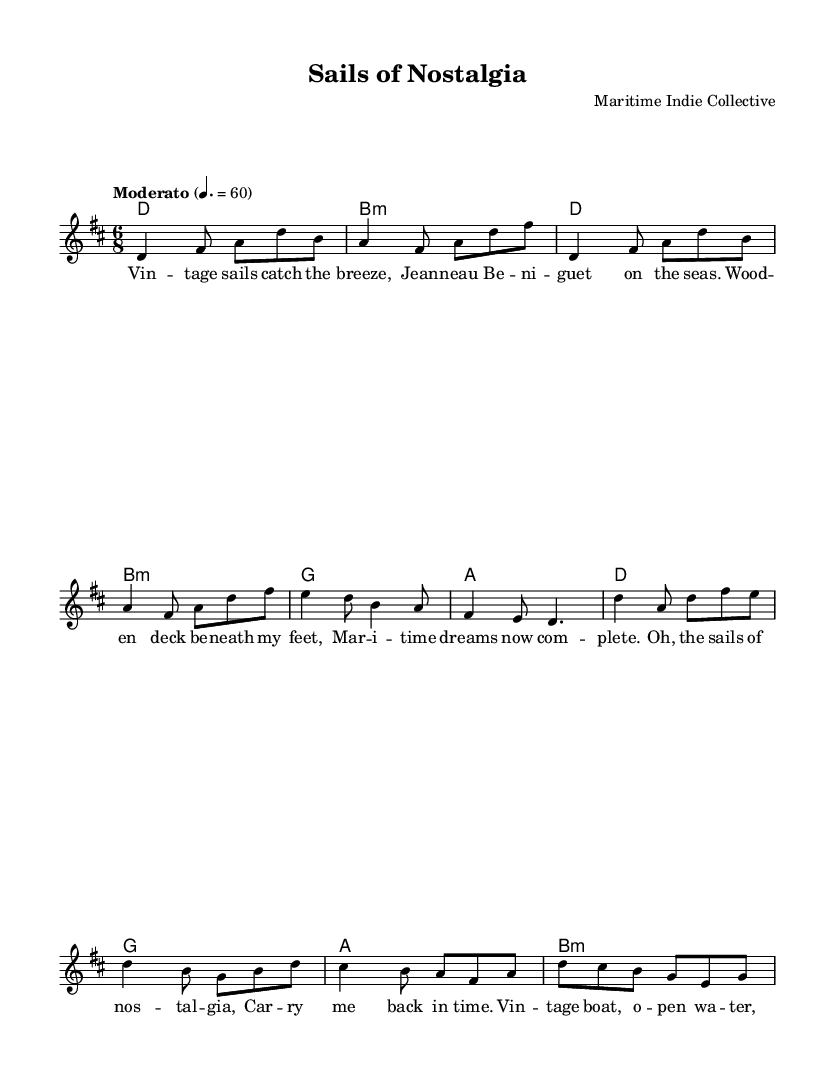What is the key signature of this music? The key signature is indicated at the beginning of the score, showing two sharps. This corresponds to the D major scale.
Answer: D major What is the time signature of this music? The time signature is shown at the beginning of the score as 6/8, indicating there are six eighth notes per measure.
Answer: 6/8 What is the tempo marking for this piece? The tempo is marked "Moderato" and also includes a metronome marking of quarter note equals 60. This indicates a moderate pace.
Answer: Moderato, 60 How many measures are in the chorus section? By counting the measures within the chorus lyrics given in the score, there are a total of 4 measures.
Answer: 4 Which vocal line is associated with the lyrics in the score? The lyrics are attached to the "melody" voice indicated in the score. This identifies which part of the music they correspond to for singing.
Answer: melody What is the chord for the chorus's first measure? The chord is indicated in the chord names section, showing D major for the first measure of the chorus.
Answer: D 